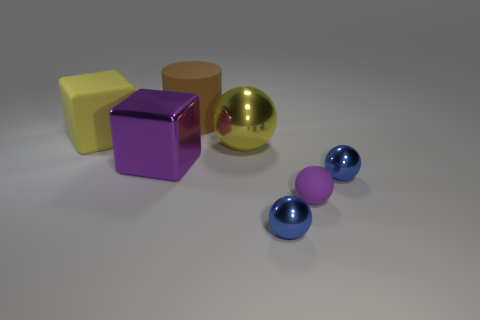Subtract all large yellow metallic balls. How many balls are left? 3 Subtract all blue balls. How many balls are left? 2 Add 3 blue metallic things. How many objects exist? 10 Subtract all brown balls. Subtract all gray cylinders. How many balls are left? 4 Subtract all cubes. How many objects are left? 5 Subtract 1 cylinders. How many cylinders are left? 0 Subtract all blue cylinders. How many yellow cubes are left? 1 Subtract all tiny purple things. Subtract all big metallic cubes. How many objects are left? 5 Add 2 big yellow objects. How many big yellow objects are left? 4 Add 1 large cubes. How many large cubes exist? 3 